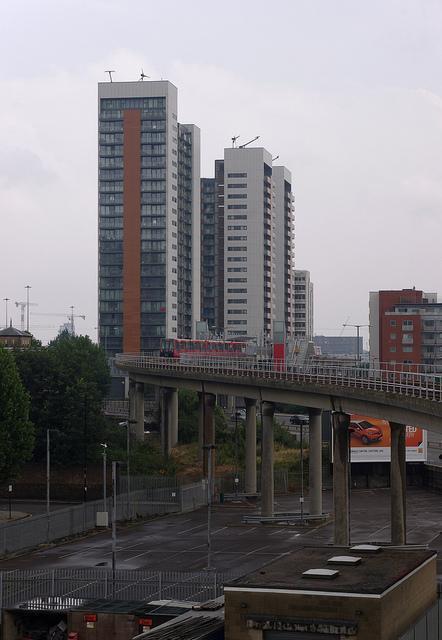How many buildings are depicted in the picture?
Give a very brief answer. 4. 